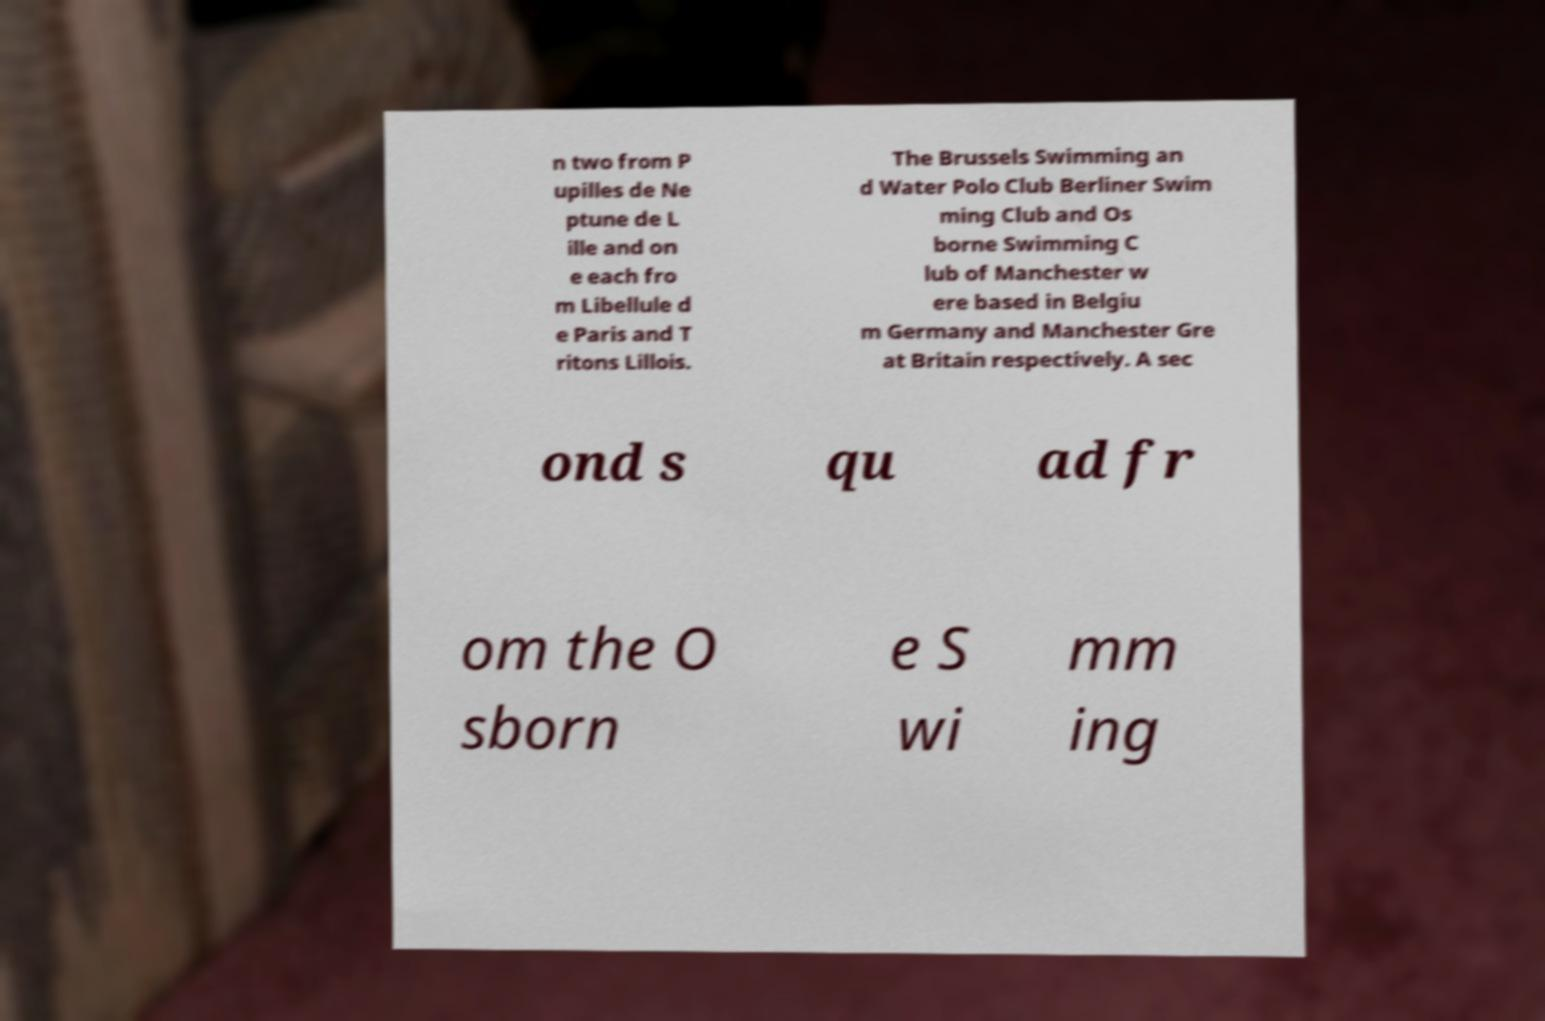Can you accurately transcribe the text from the provided image for me? n two from P upilles de Ne ptune de L ille and on e each fro m Libellule d e Paris and T ritons Lillois. The Brussels Swimming an d Water Polo Club Berliner Swim ming Club and Os borne Swimming C lub of Manchester w ere based in Belgiu m Germany and Manchester Gre at Britain respectively. A sec ond s qu ad fr om the O sborn e S wi mm ing 